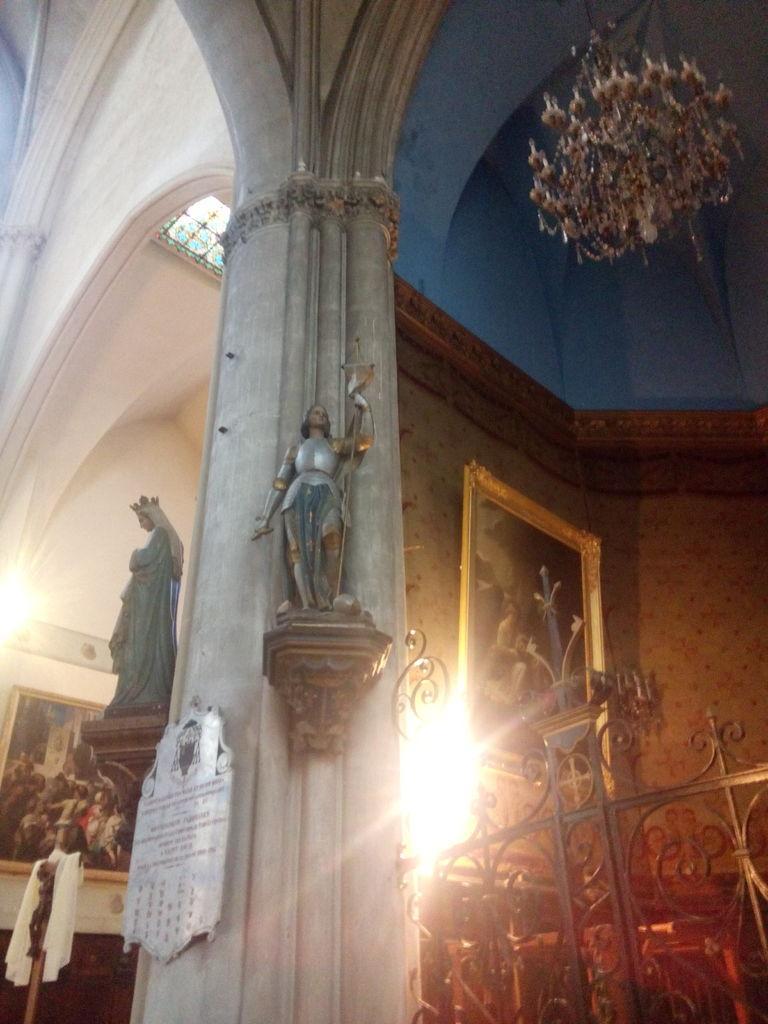Describe this image in one or two sentences. I think this picture was taken inside the building. These are the sculptures. This looks like a pillar. I can see the photo frames, which are attached to the wall. This looks like a board, which is attached to a pillar. I think this is an iron grill. This looks like a chandelier, which is hanging. I think this is a window. 